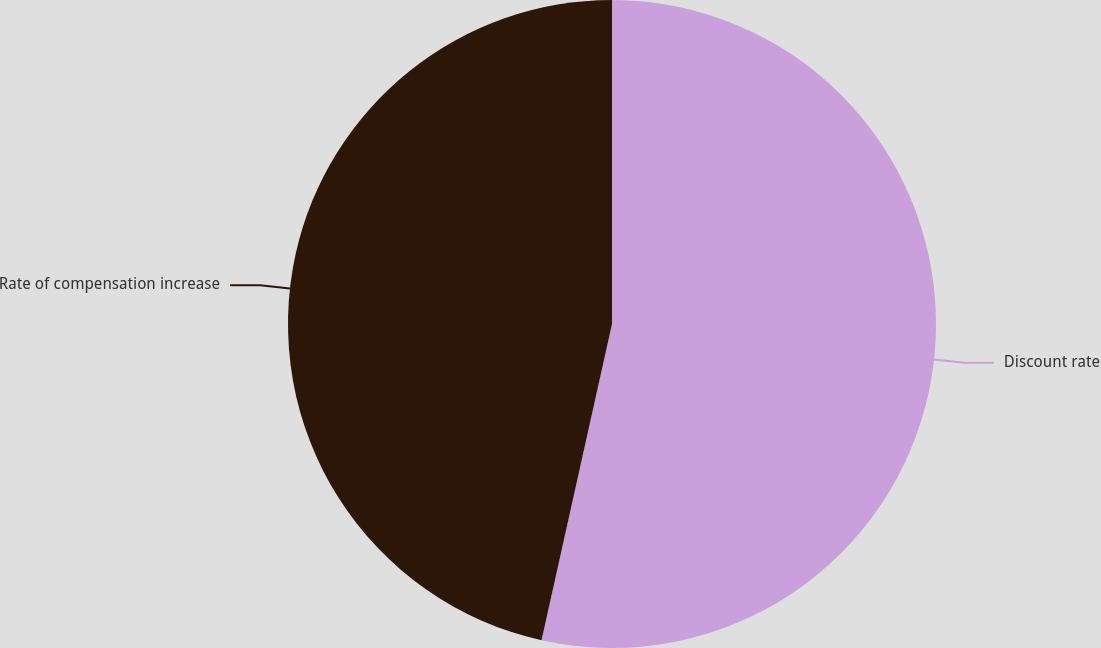Convert chart to OTSL. <chart><loc_0><loc_0><loc_500><loc_500><pie_chart><fcel>Discount rate<fcel>Rate of compensation increase<nl><fcel>53.49%<fcel>46.51%<nl></chart> 